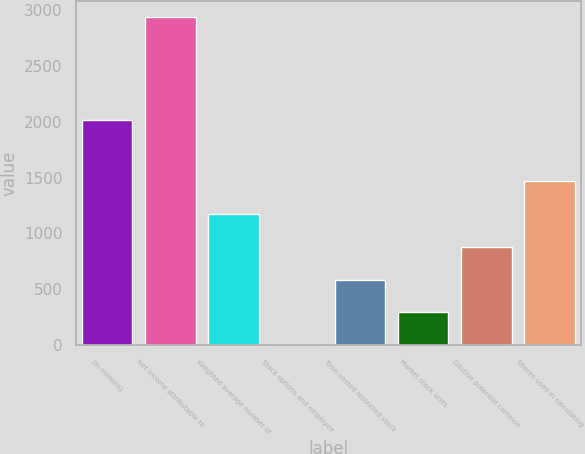Convert chart to OTSL. <chart><loc_0><loc_0><loc_500><loc_500><bar_chart><fcel>(In millions)<fcel>Net income attributable to<fcel>Weighted average number of<fcel>Stock options and employee<fcel>Time-vested restricted stock<fcel>Market stock units<fcel>Dilutive potential common<fcel>Shares used in calculating<nl><fcel>2014<fcel>2934.8<fcel>1173.98<fcel>0.1<fcel>587.04<fcel>293.57<fcel>880.51<fcel>1467.45<nl></chart> 